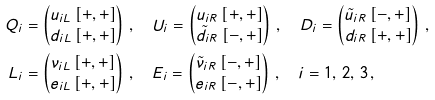<formula> <loc_0><loc_0><loc_500><loc_500>Q _ { i } & = \begin{pmatrix} u _ { i L } \, [ + , + ] \\ d _ { i L } \, [ + , + ] \end{pmatrix} \, , \quad U _ { i } = \begin{pmatrix} u _ { i R } \, [ + , + ] \\ \tilde { d } _ { i R } \, [ - , + ] \end{pmatrix} \, , \quad D _ { i } = \begin{pmatrix} \tilde { u } _ { i R } \, [ - , + ] \\ d _ { i R } \, [ + , + ] \end{pmatrix} \, , \\ L _ { i } & = \begin{pmatrix} \nu _ { i L } \, [ + , + ] \\ e _ { i L } \, [ + , + ] \end{pmatrix} \, , \quad E _ { i } = \begin{pmatrix} \tilde { \nu } _ { i R } \, [ - , + ] \\ e _ { i R } \, [ - , + ] \end{pmatrix} \, , \quad i = 1 , \, 2 , \, 3 \, ,</formula> 